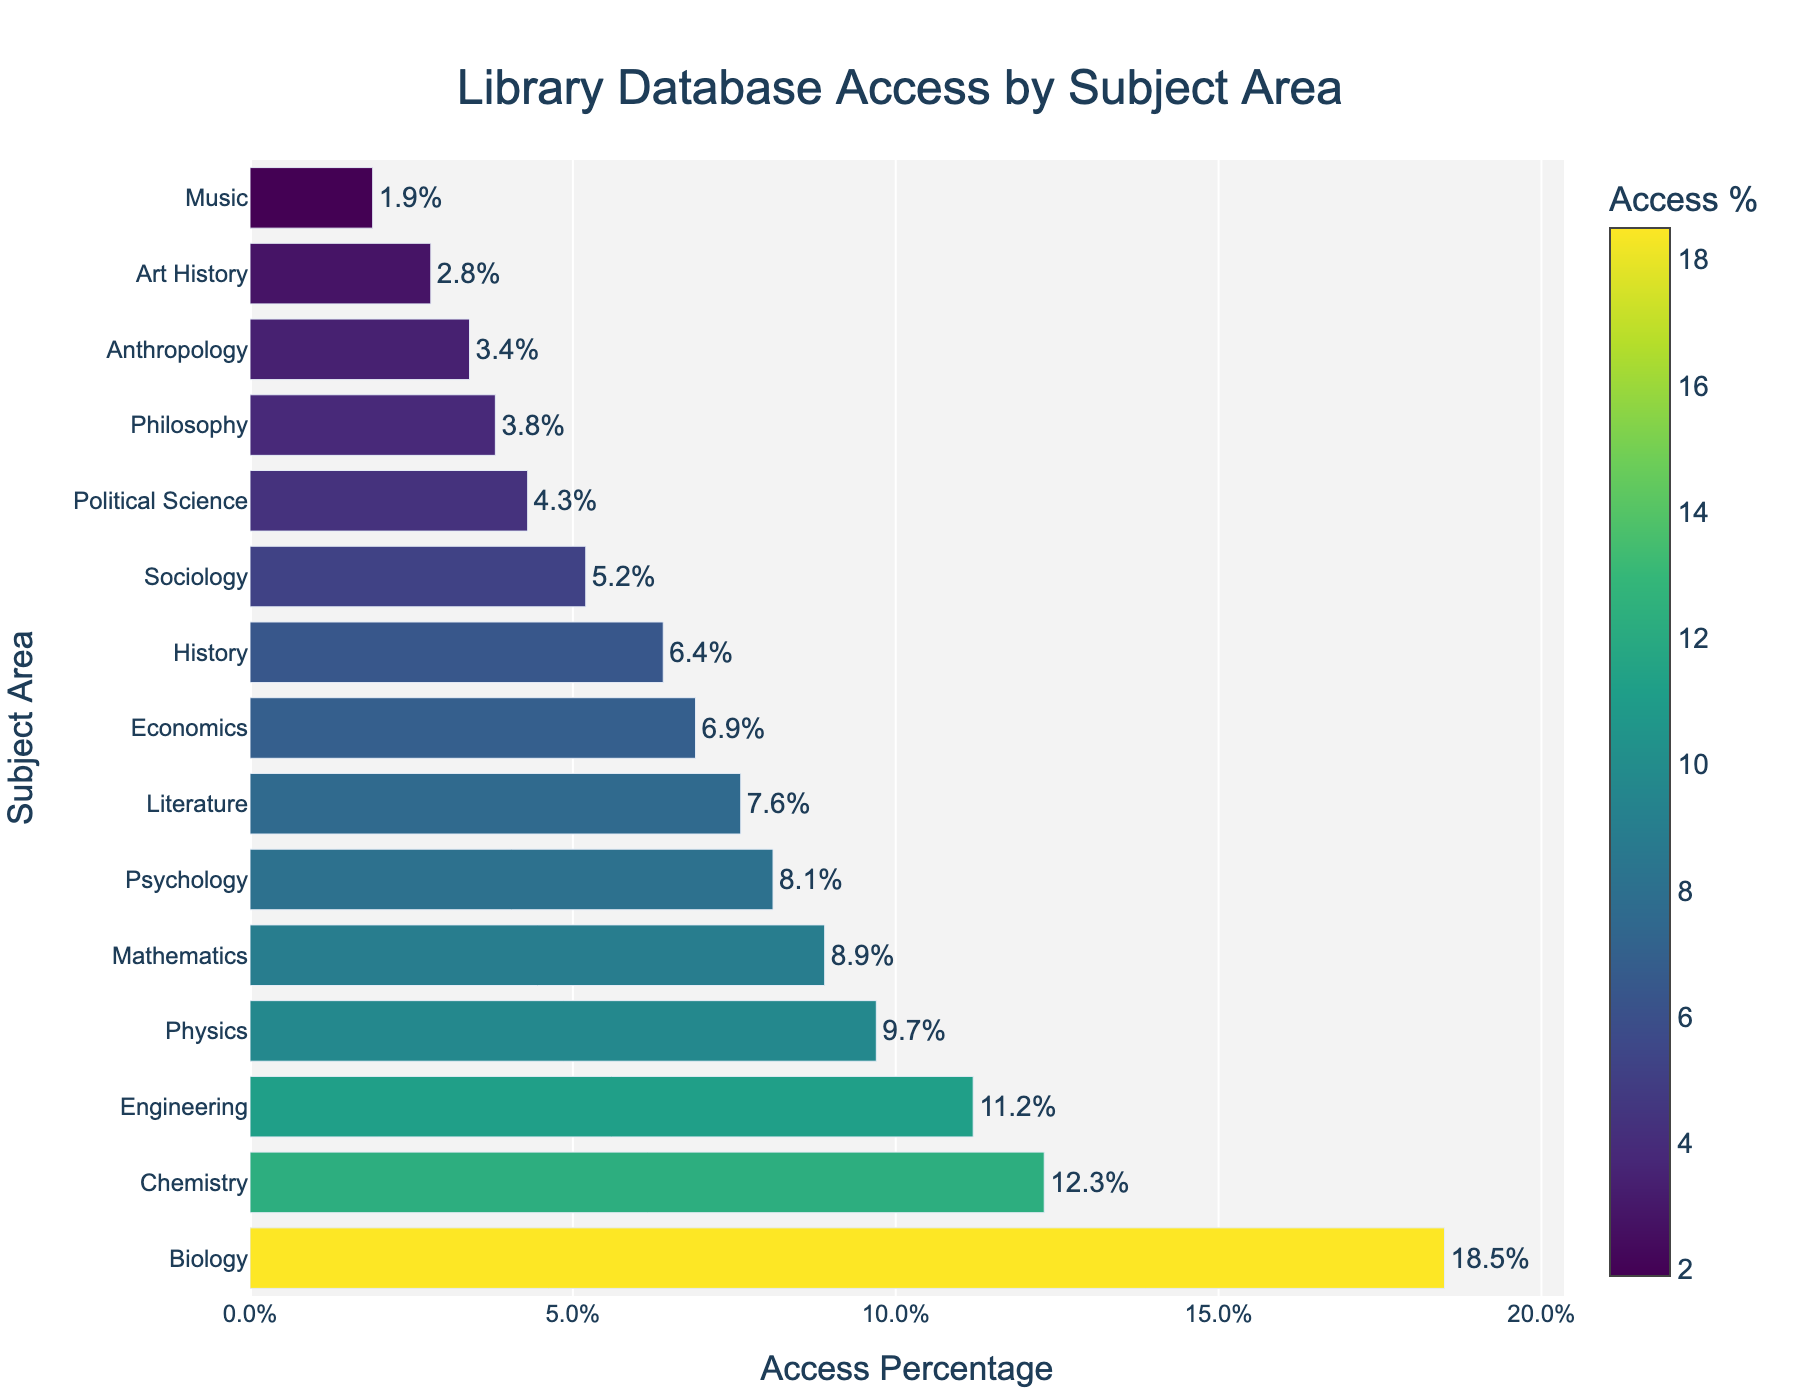Which subject area has the highest database access percentage? The bar chart shows that Biology has the longest bar, indicating the highest access percentage.
Answer: Biology Which subject area has the lowest database access percentage? The bar chart shows that Music has the shortest bar, indicating the lowest access percentage.
Answer: Music What is the access percentage difference between Biology and Chemistry? Biology's access percentage is 18.5%, and Chemistry's is 12.3%. The difference is calculated as 18.5% - 12.3%.
Answer: 6.2% How many subject areas have an access percentage greater than 10%? The subject areas with access percentages greater than 10% are Biology (18.5%), Chemistry (12.3%), and Engineering (11.2%). Count these subject areas.
Answer: 3 What's the total access percentage for all the humanities-related subject areas? Humanities-related subject areas include Literature, History, Philosophy, Art History, and Music. Sum their access percentages: 7.6 + 6.4 + 3.8 + 2.8 + 1.9.
Answer: 22.5% Compare the access percentage of Sociology with Political Science. Which one has higher access? The bar chart shows Sociology has an access percentage of 5.2%, while Political Science has 4.3%.
Answer: Sociology What is the average access percentage of all subject areas? Sum all access percentages and divide by the number of subject areas: (18.5 + 12.3 + 9.7 + 11.2 + 8.9 + 7.6 + 6.4 + 3.8 + 8.1 + 5.2 + 4.3 + 6.9 + 2.8 + 1.9 + 3.4) / 15.
Answer: 7.1 Which subject areas have an access percentage below 5%? The subject areas with access percentages below 5% are Philosophy (3.8%), Political Science (4.3%), Art History (2.8%), Music (1.9%), and Anthropology (3.4%).
Answer: Philosophy, Political Science, Art History, Music, Anthropology What is the combined access percentage for all science-related subjects? Science-related subjects include Biology, Chemistry, Physics, Engineering, and Mathematics. Sum their access percentages: 18.5 + 12.3 + 9.7 + 11.2 + 8.9.
Answer: 60.6% How much higher is the access percentage for Psychology compared to Economics? Psychology's access percentage is 8.1%, and Economics' is 6.9%. The difference is calculated as 8.1% - 6.9%.
Answer: 1.2% 